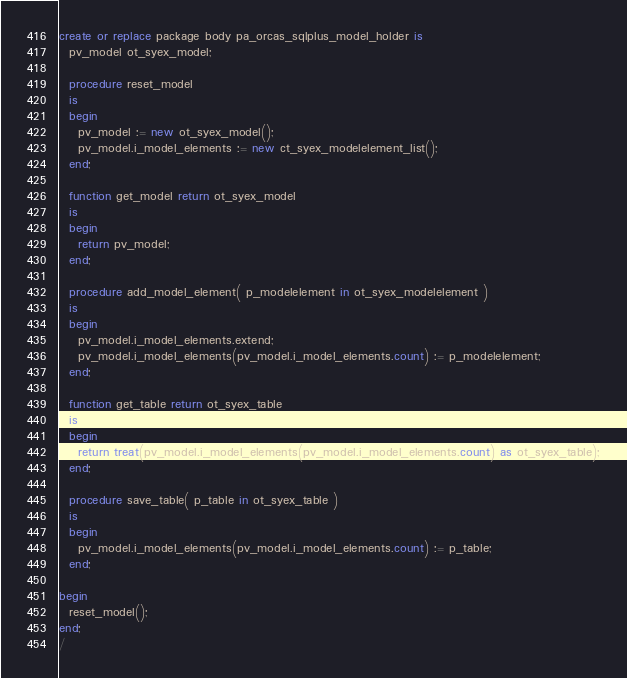Convert code to text. <code><loc_0><loc_0><loc_500><loc_500><_SQL_>create or replace package body pa_orcas_sqlplus_model_holder is
  pv_model ot_syex_model;

  procedure reset_model
  is
  begin
    pv_model := new ot_syex_model();
    pv_model.i_model_elements := new ct_syex_modelelement_list();
  end;

  function get_model return ot_syex_model
  is
  begin
    return pv_model;
  end;

  procedure add_model_element( p_modelelement in ot_syex_modelelement )
  is
  begin
    pv_model.i_model_elements.extend;
    pv_model.i_model_elements(pv_model.i_model_elements.count) := p_modelelement;
  end;

  function get_table return ot_syex_table
  is
  begin
    return treat(pv_model.i_model_elements(pv_model.i_model_elements.count) as ot_syex_table);
  end;

  procedure save_table( p_table in ot_syex_table )
  is
  begin
    pv_model.i_model_elements(pv_model.i_model_elements.count) := p_table;
  end;

begin
  reset_model();
end;
/
</code> 